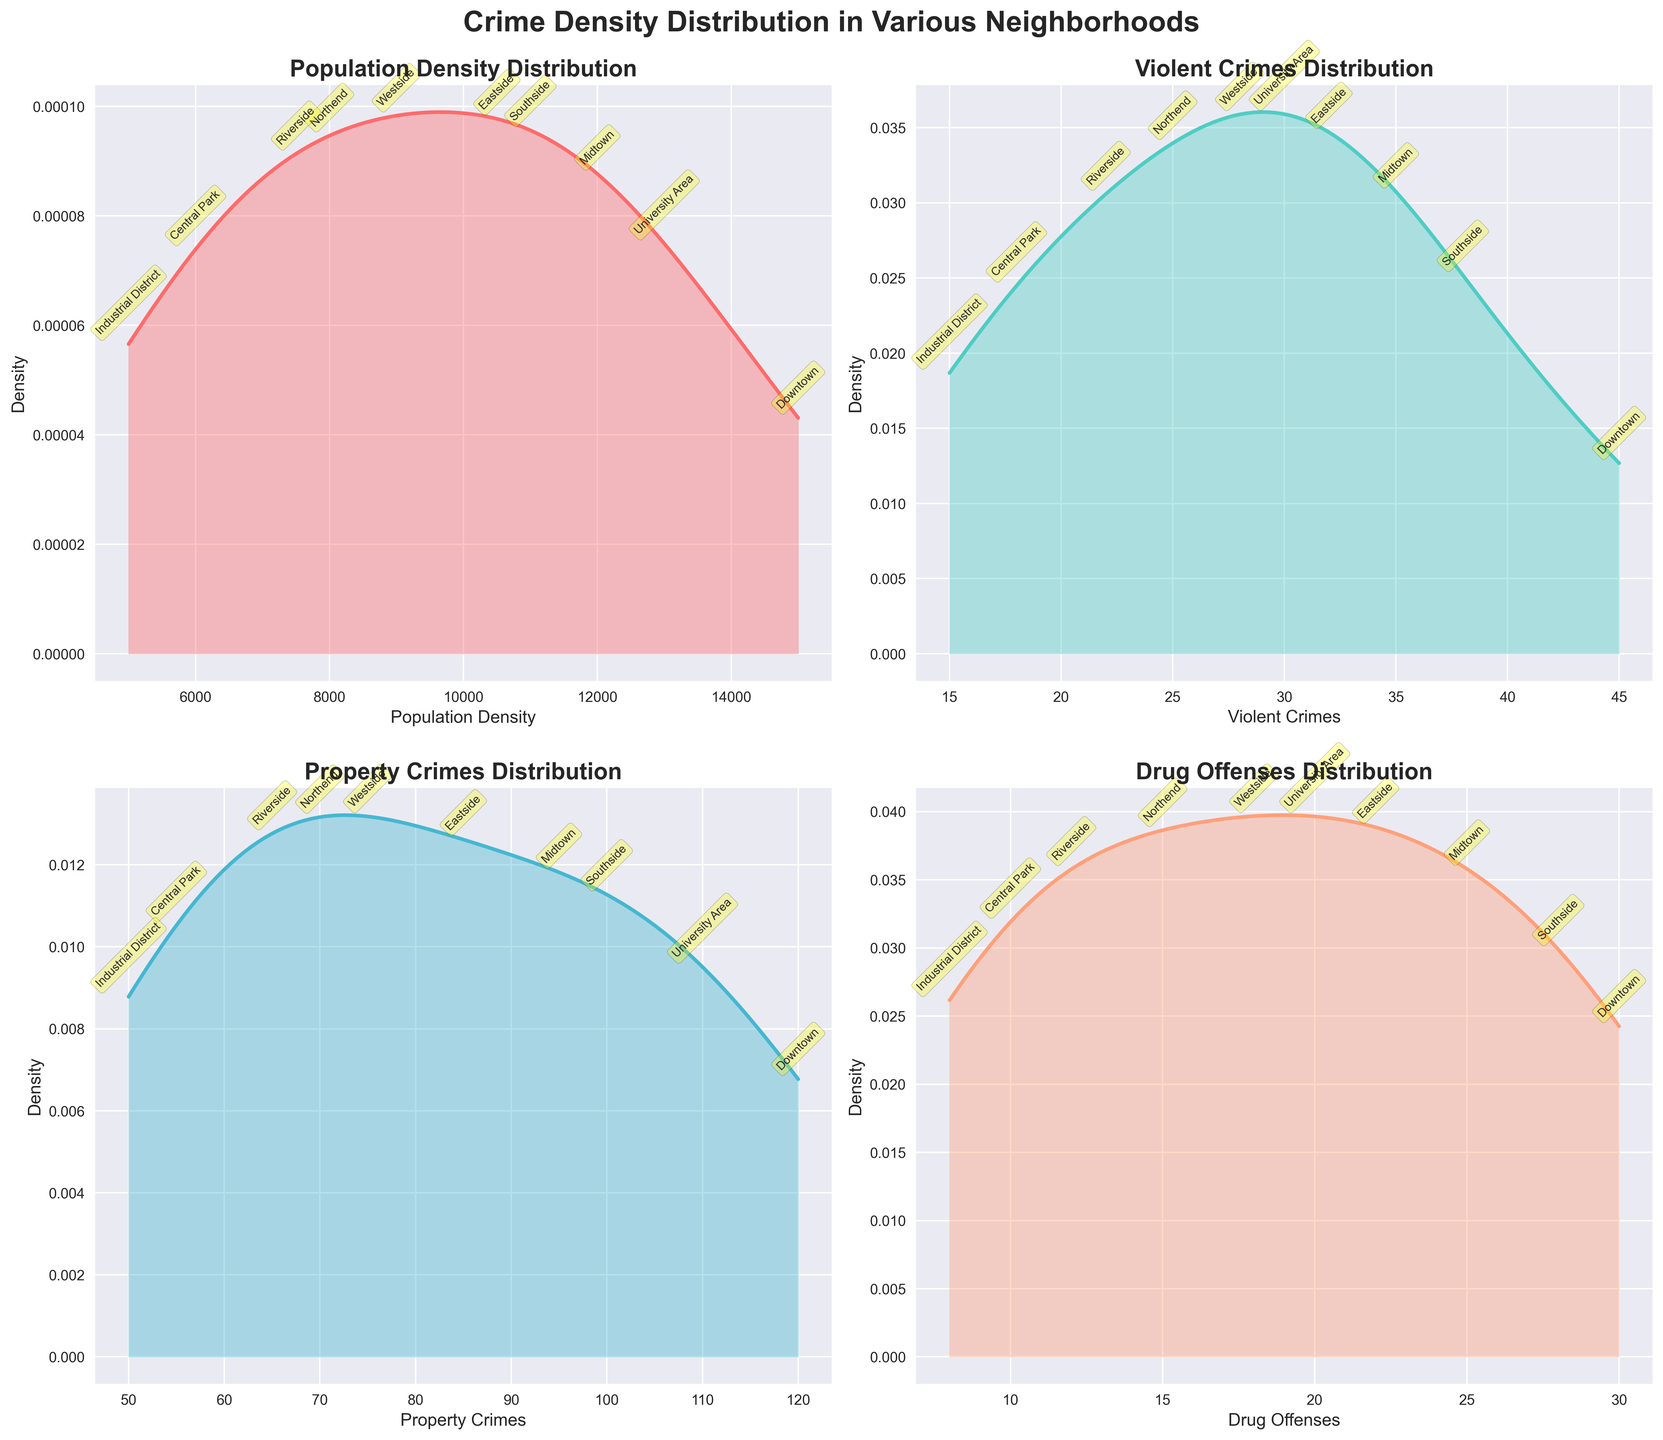What's the title of the figure? The title is usually located at the top of the figure and summarizes the entire plot's main idea. Here, it should be the text at the top-center of the figure.
Answer: Crime Density Distribution in Various Neighborhoods What is plotted on the x-axis of the Population Density Distribution subplot? The x-axis indicates what variable is being measured. In the Population Density subplot, it shows "Population Density" as labeled on the plot.
Answer: Population Density How does the density distribution of Violent Crimes compare to that of Drug Offenses? To compare, observe the shapes and peaks of the density curves for both Violent Crimes and Drug Offenses subplots. Violent Crimes have a higher and sharper peak compared to the broader distribution of Drug Offenses.
Answer: Violent Crimes have a sharper peak Which neighborhood has the highest population density, and what is its approximate value? By looking at the annotations on the Population Density subplot, find the neighborhood labeled at the highest point on the x-axis. Downtown has the highest population density, approximately 15,000.
Answer: Downtown, 15,000 Which crime type has the smallest range in values across neighborhoods? To determine the range, examine the x-axis of each subplot: the one with the smallest spread from minimum to maximum is the Drug Offenses.
Answer: Drug Offenses What neighborhood has the highest violent crime rate, and what is that rate? On the Violent Crimes density plot, identify the highest labeled point. Downtown shows the highest rate of approximately 45 violent crimes.
Answer: Downtown, 45 Are there any neighborhoods with similar property crime rates? Check the Property Crimes subplot and compare values close together. Midtown and University Area have similar rates, around 95-110 property crimes.
Answer: Midtown and University Area What's the approximate density peak for drug offenses? Look at where the Drug Offenses curve reaches its highest point on the y-axis. The peak seems around 0.0004.
Answer: 0.0004 Which neighborhood has the lowest property crime rate, and what is that rate? On the Property Crimes plot, find the annotated neighborhood at the lowest x-axis value. The Industrial District has the lowest, approximately 50 property crimes.
Answer: Industrial District, 50 